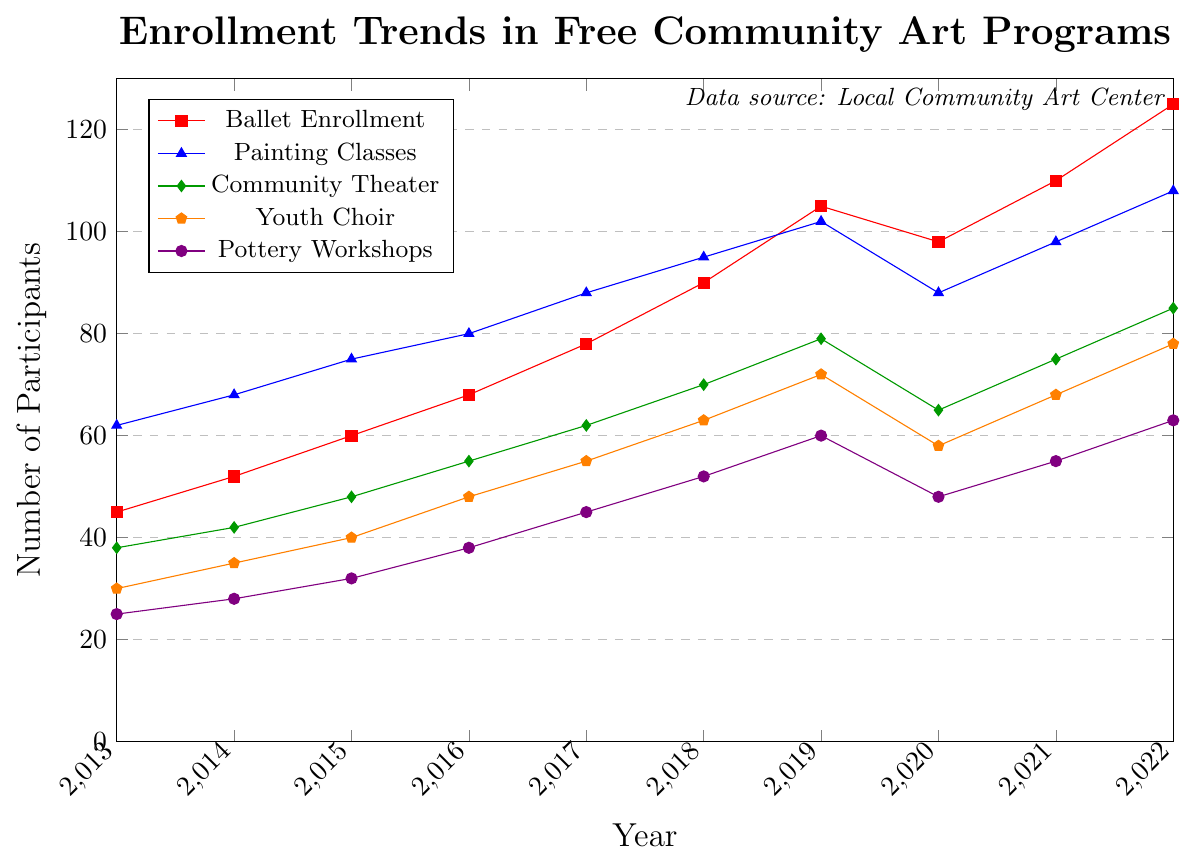What's the highest enrollment value for Ballet classes? The highest enrollment value for Ballet classes can be found at the peak in the line chart representing Ballet Enrollment. Looking at the chart, the peak is in 2022 where the enrollment is 125 participants.
Answer: 125 Compare the number of participants in the Pottery Workshops between 2013 and 2014. Which year had more participants, and by how many? Count the number of participants for Pottery Workshops for both years and find the difference. 2014 had 28 participants and 2013 had 25 participants, so 2014 had 28 - 25 = 3 more participants than 2013.
Answer: 2014 had 3 more participants What was the trend in Youth Choir enrollment from 2013 to 2022? To identify the trend, observe the line for Youth Choir in the chart. The enrollment shows a steady increase throughout the years, starting with 30 participants in 2013 and reaching 78 participants in 2022, despite a slight dip in 2020.
Answer: Increasing trend Which program had the highest drop in enrollment from 2019 to 2020? Inspect the lines for each program between the years 2019 and 2020 for the steepest descent. Ballet dropped from 105 to 98, Painting Classes from 102 to 88, Community Theater from 79 to 65, Youth Choir from 72 to 58, and Pottery Workshops from 60 to 48. The largest drop is in Painting Classes, which dropped by 14 participants (102 - 88 = 14).
Answer: Painting Classes Calculate the average enrollment for Painting Classes over the decade. Add the enrollment numbers for Painting Classes from 2013 to 2022 and then divide by the number of years. So, the calculation is (62 + 68 + 75 + 80 + 88 + 95 + 102 + 88 + 98 + 108) / 10, which equals 854 / 10 = 85.4.
Answer: 85.4 Between Community Theater and Youth Choir, which program saw a greater total increase in enrollment from 2013 to 2022? Calculate the difference in enrollment for each program between the start year 2013 and the end year 2022. For Community Theater: 85 - 38 = 47. For Youth Choir: 78 - 30 = 48. Comparing both values, Youth Choir had a greater increase.
Answer: Youth Choir What is the combined enrollment for Ballet and Pottery Workshops in 2017? Locate the enrollment values for Ballet and Pottery Workshops in 2017. Ballet has 78 and Pottery Workshops have 45 participants. The combined total enrollment is 78 + 45 = 123.
Answer: 123 